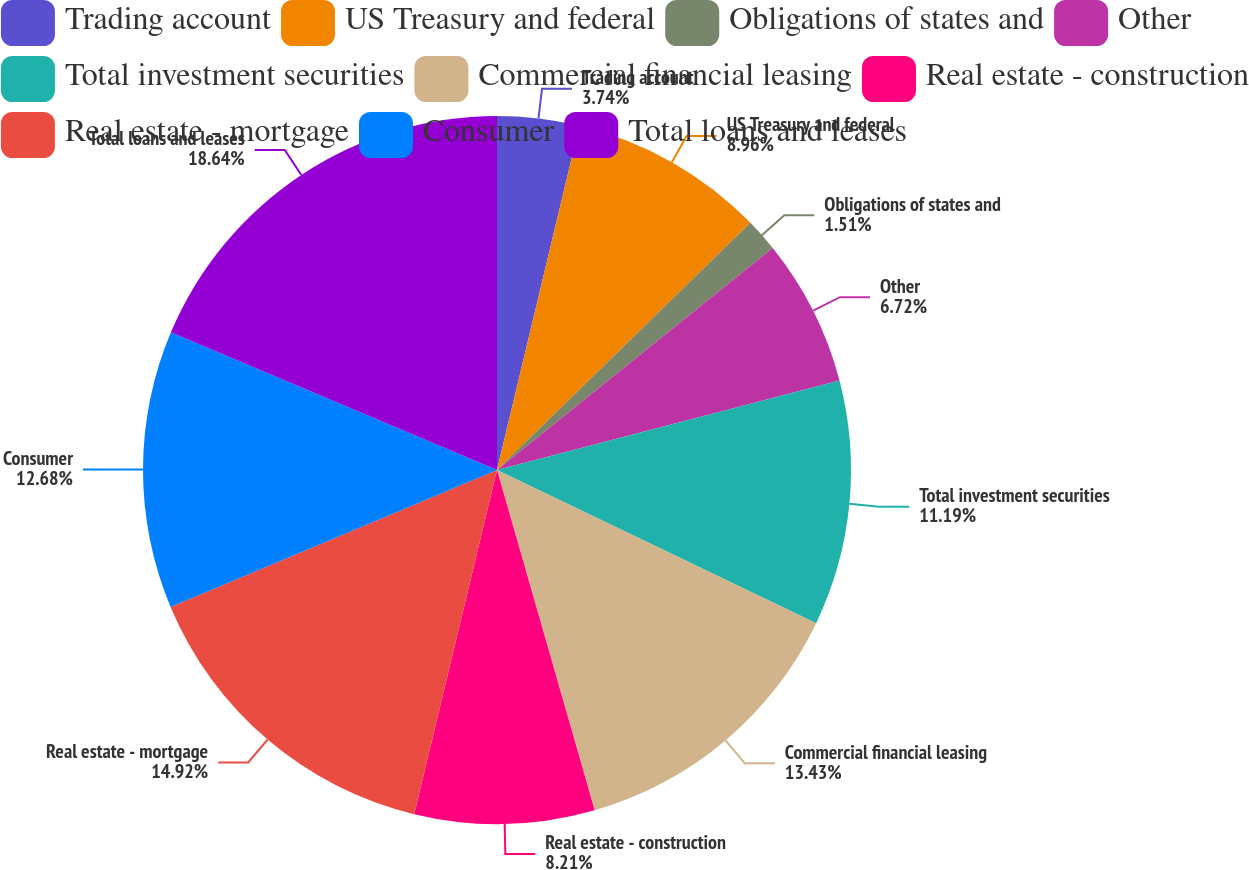Convert chart. <chart><loc_0><loc_0><loc_500><loc_500><pie_chart><fcel>Trading account<fcel>US Treasury and federal<fcel>Obligations of states and<fcel>Other<fcel>Total investment securities<fcel>Commercial financial leasing<fcel>Real estate - construction<fcel>Real estate - mortgage<fcel>Consumer<fcel>Total loans and leases<nl><fcel>3.74%<fcel>8.96%<fcel>1.51%<fcel>6.72%<fcel>11.19%<fcel>13.43%<fcel>8.21%<fcel>14.92%<fcel>12.68%<fcel>18.64%<nl></chart> 